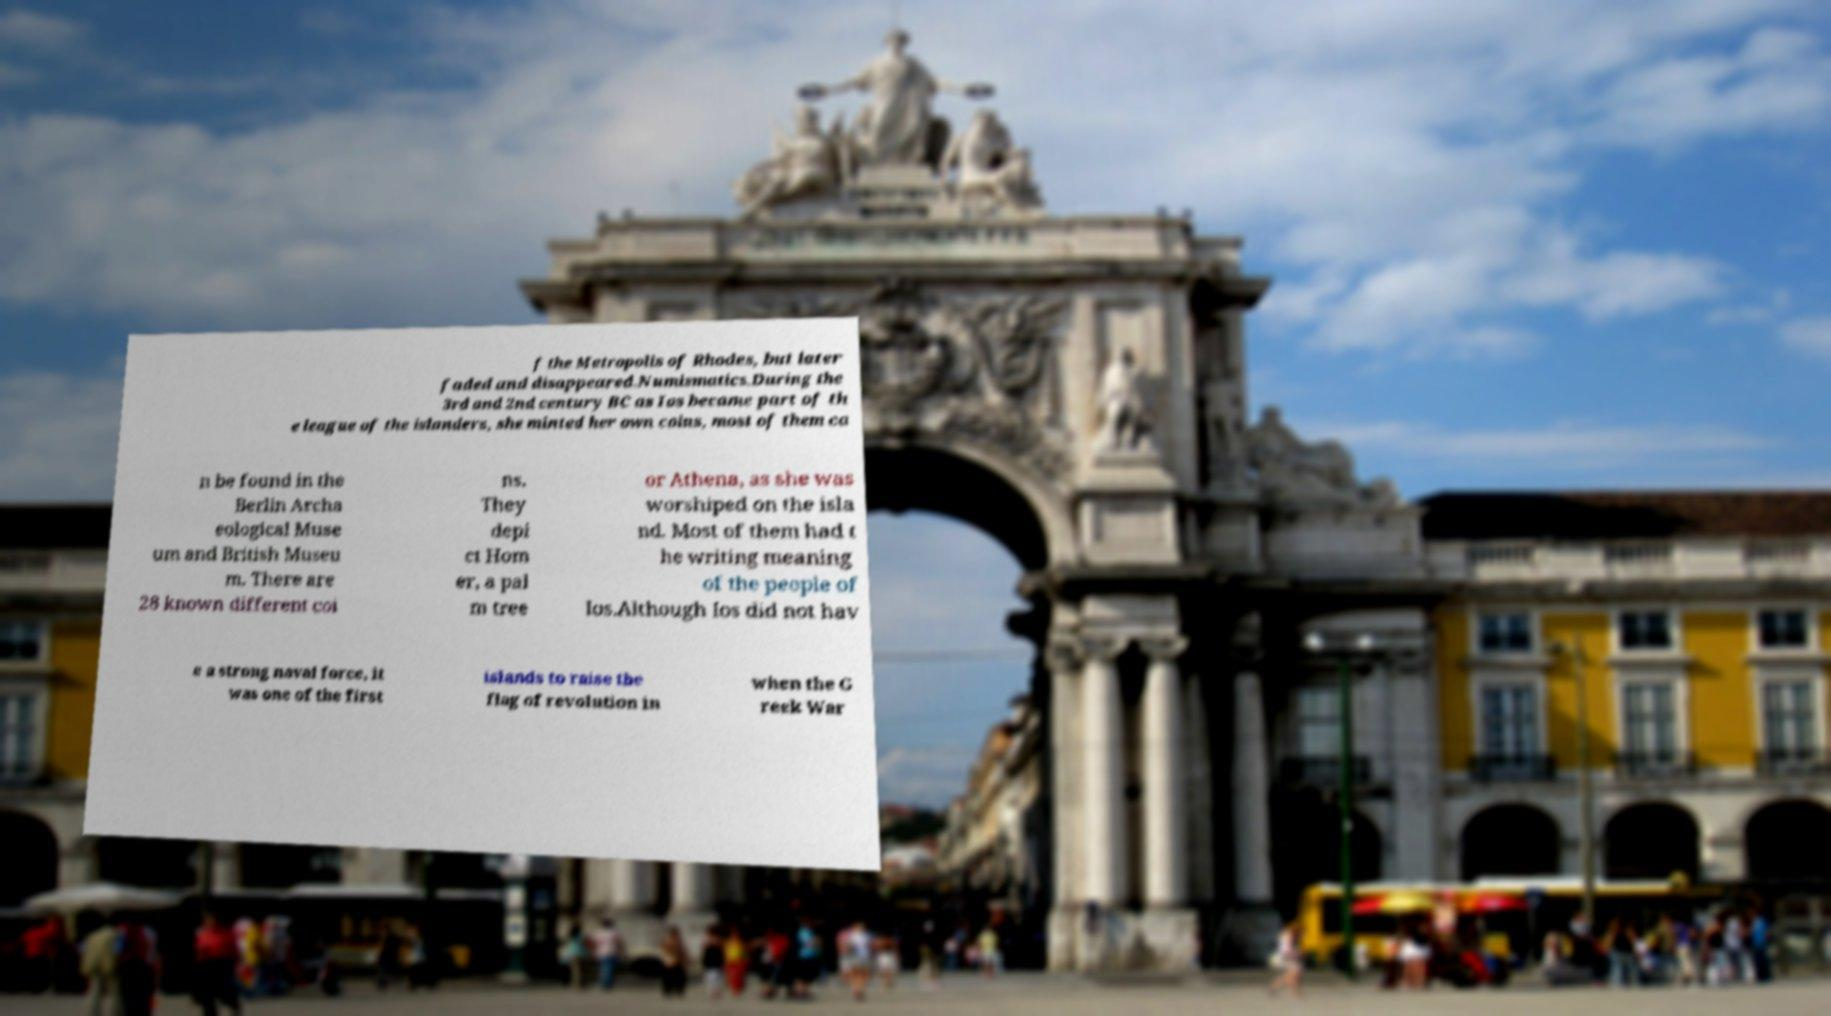Could you extract and type out the text from this image? f the Metropolis of Rhodes, but later faded and disappeared.Numismatics.During the 3rd and 2nd century BC as Ios became part of th e league of the islanders, she minted her own coins, most of them ca n be found in the Berlin Archa eological Muse um and British Museu m. There are 28 known different coi ns. They depi ct Hom er, a pal m tree or Athena, as she was worshiped on the isla nd. Most of them had t he writing meaning of the people of Ios.Although Ios did not hav e a strong naval force, it was one of the first islands to raise the flag of revolution in when the G reek War 